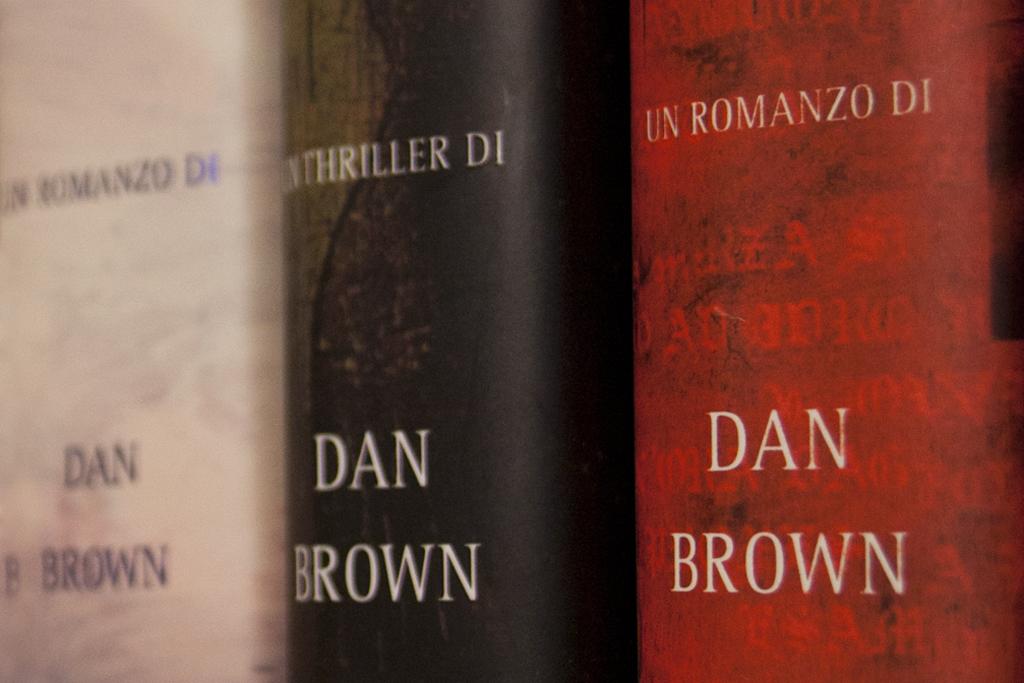Are these books written in italian?
Offer a terse response. Yes. 